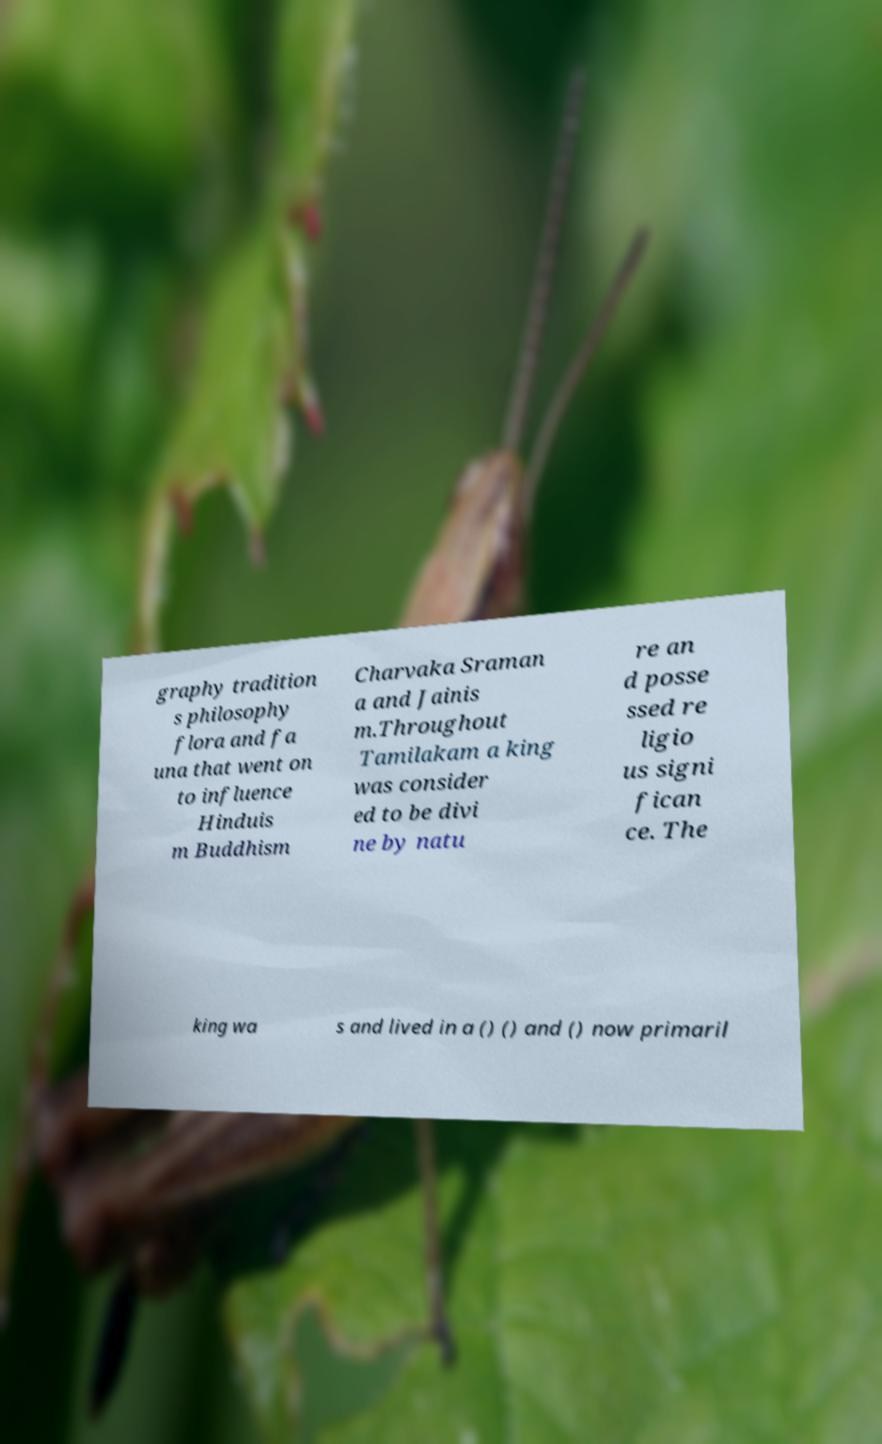Please identify and transcribe the text found in this image. graphy tradition s philosophy flora and fa una that went on to influence Hinduis m Buddhism Charvaka Sraman a and Jainis m.Throughout Tamilakam a king was consider ed to be divi ne by natu re an d posse ssed re ligio us signi fican ce. The king wa s and lived in a () () and () now primaril 